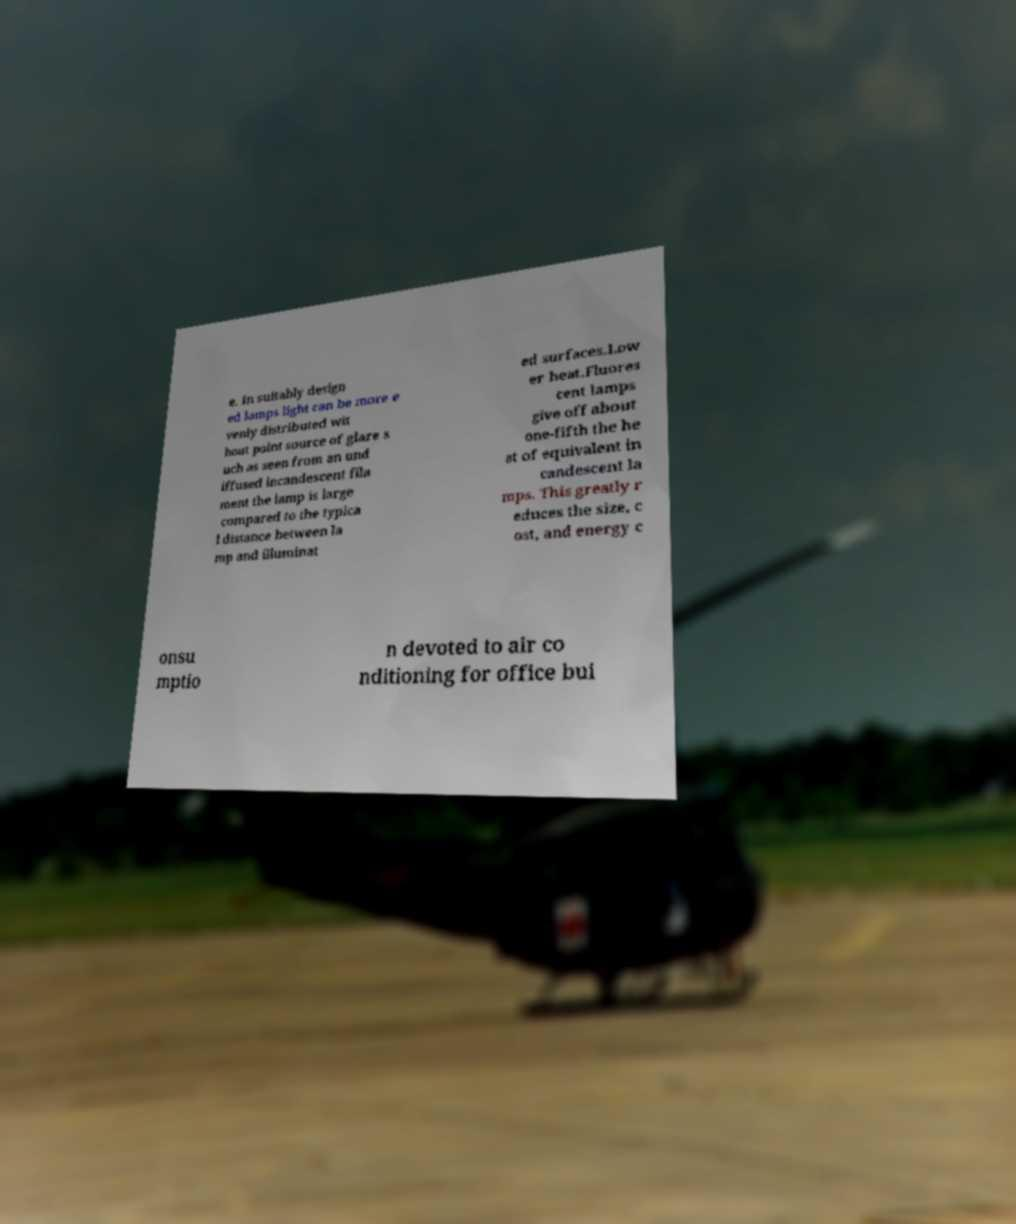Could you extract and type out the text from this image? e. In suitably design ed lamps light can be more e venly distributed wit hout point source of glare s uch as seen from an und iffused incandescent fila ment the lamp is large compared to the typica l distance between la mp and illuminat ed surfaces.Low er heat.Fluores cent lamps give off about one-fifth the he at of equivalent in candescent la mps. This greatly r educes the size, c ost, and energy c onsu mptio n devoted to air co nditioning for office bui 